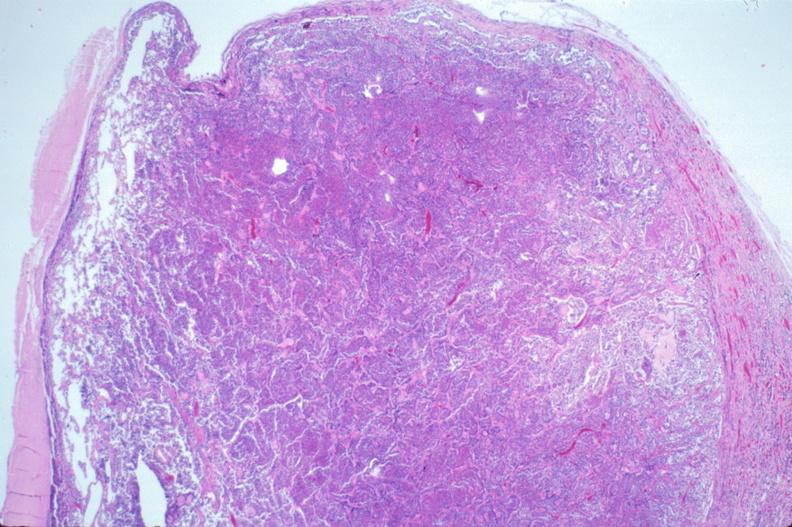what does this image show?
Answer the question using a single word or phrase. Pituitary 